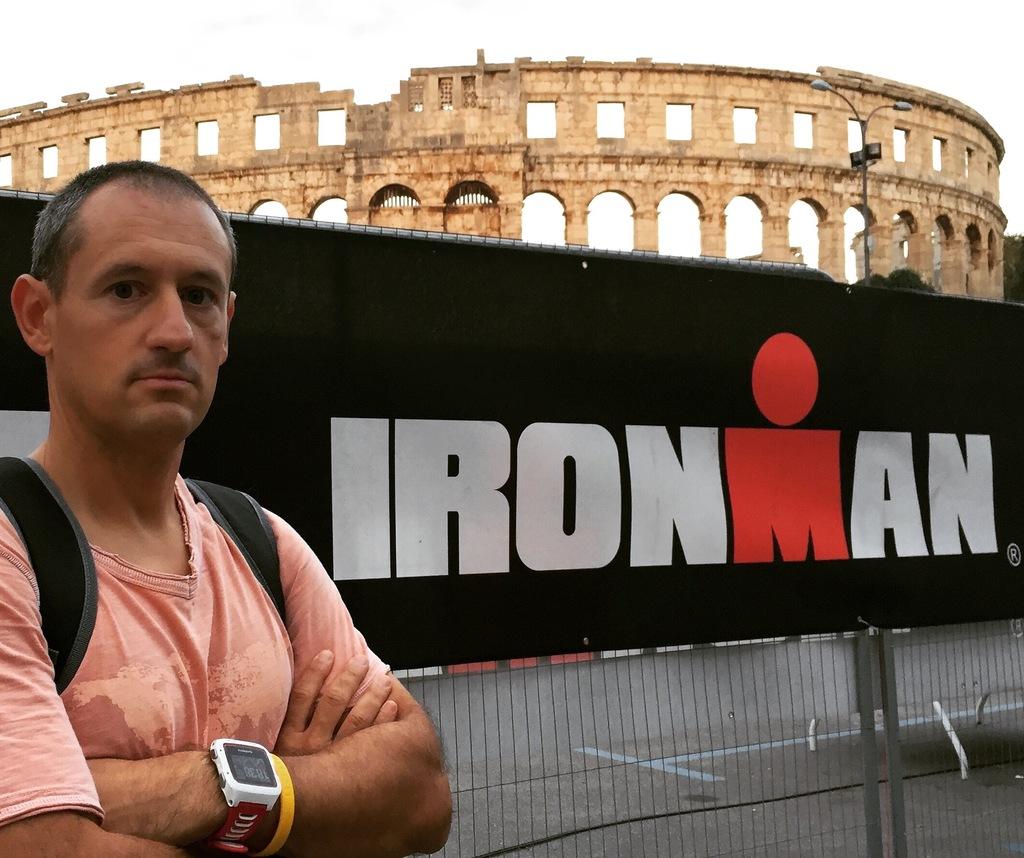What kind of man?
Offer a very short reply. Ironman. What is the name of this drink?
Give a very brief answer. Unanswerable. 